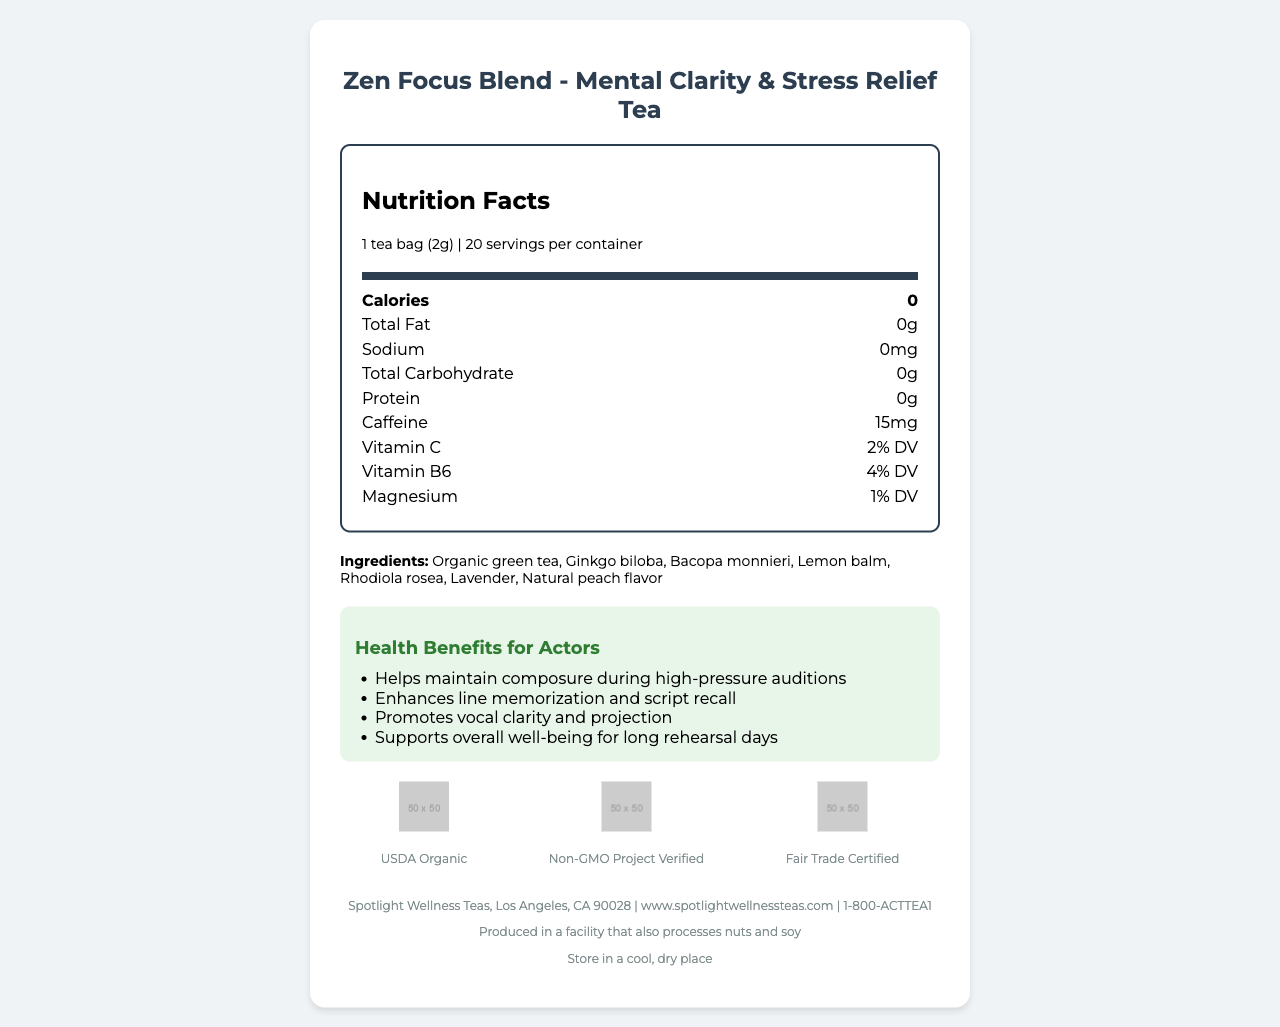what is the serving size? The serving size is listed at the beginning of the nutrition label and is indicated as "1 tea bag (2g)."
Answer: 1 tea bag (2g) how many servings are in one container? The label specifies that there are 20 servings per container.
Answer: 20 what is the caffeine content per serving? The caffeine content is listed under the nutrition facts section as 15mg per serving.
Answer: 15mg which specific vitamins and minerals are contained in the tea? The vitamins and minerals present are listed with their daily values: Vitamin C (2% DV), Vitamin B6 (4% DV), and Magnesium (1% DV).
Answer: Vitamin C, Vitamin B6, Magnesium what is the main ingredient in the tea? The first ingredient listed in the ingredients section is "Organic green tea."
Answer: Organic green tea is the tea certified organic? The certification section shows a "USDA Organic" label, confirming it is organic.
Answer: Yes what are the benefits of drinking this tea for actors? These specific benefits for actors are listed under the "Health Benefits for Actors" section.
Answer: Helps maintain composure during high-pressure auditions, Enhances line memorization and script recall, Promotes vocal clarity and projection, Supports overall well-being for long rehearsal days which of the following is not an ingredient in the tea?
A. Lavender
B. Chamomile
C. Ginkgo biloba The ingredients list includes Lavender and Ginkgo biloba but does not mention Chamomile.
Answer: B where is the tea blend sourced from?
i. India, China, and Europe
ii. Africa, South America, and Australia
iii. North America, Asia, and Europe The document states the blend is sourced from organic farms in India, China, and Europe.
Answer: i. India, China, and Europe does the tea provide any caloric intake? According to the nutrition facts, the tea has 0 calories.
Answer: No provide a summary of the entire document The summary captures all key sections of the document, highlighting its main points like nutritional details, ingredients, health benefits, certifications, and additional relevant information.
Answer: The document is a Nutrition Facts Label for "Zen Focus Blend - Mental Clarity & Stress Relief Tea." It details nutritional information per serving, including 0 calories, 0 fat, 15mg of caffeine, and minor amounts of Vitamin C, B6, and Magnesium. The ingredients include organic green tea, various herbs, and natural flavor. The tea offers multiple health benefits, especially for actors, such as improved mental clarity, stress relief, and better vocal projection. It is certified organic, non-GMO, and fair trade. Preparation and storage instructions and customer service details are also provided. can I find details about the manufacturing process of the tea in this document? The document provides details on the ingredients, nutritional facts, and certifications but does not include any specifics about the manufacturing process.
Answer: Not enough information 